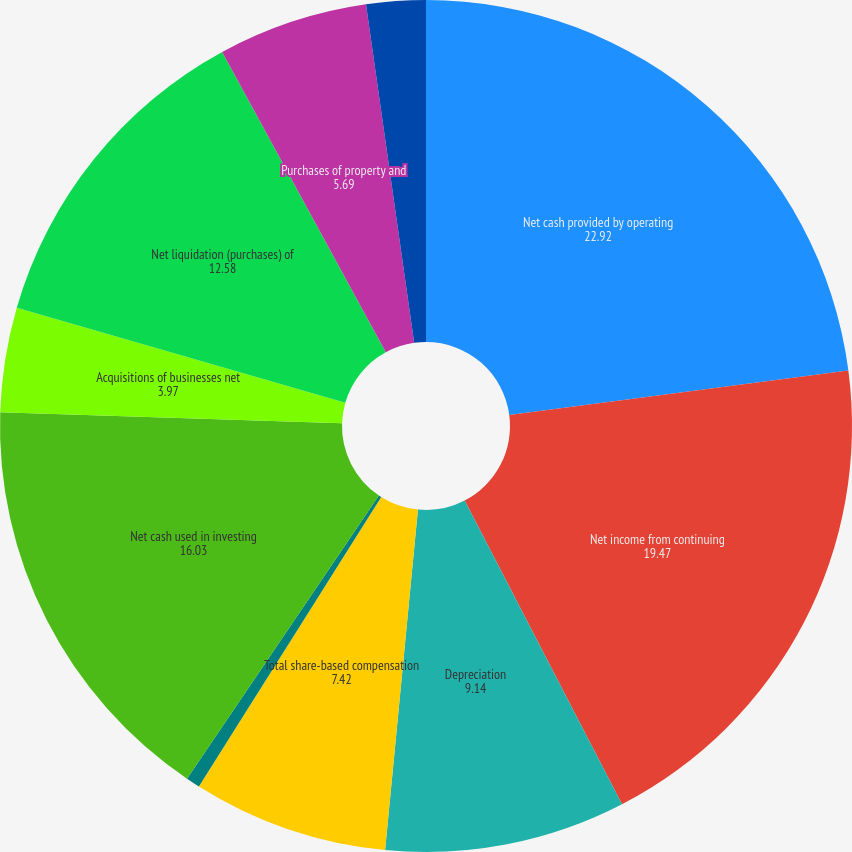Convert chart. <chart><loc_0><loc_0><loc_500><loc_500><pie_chart><fcel>Net cash provided by operating<fcel>Net income from continuing<fcel>Depreciation<fcel>Total share-based compensation<fcel>Acquisition-related costs<fcel>Net cash used in investing<fcel>Acquisitions of businesses net<fcel>Net liquidation (purchases) of<fcel>Purchases of property and<fcel>Capitalization of internal use<nl><fcel>22.92%<fcel>19.47%<fcel>9.14%<fcel>7.42%<fcel>0.53%<fcel>16.03%<fcel>3.97%<fcel>12.58%<fcel>5.69%<fcel>2.25%<nl></chart> 